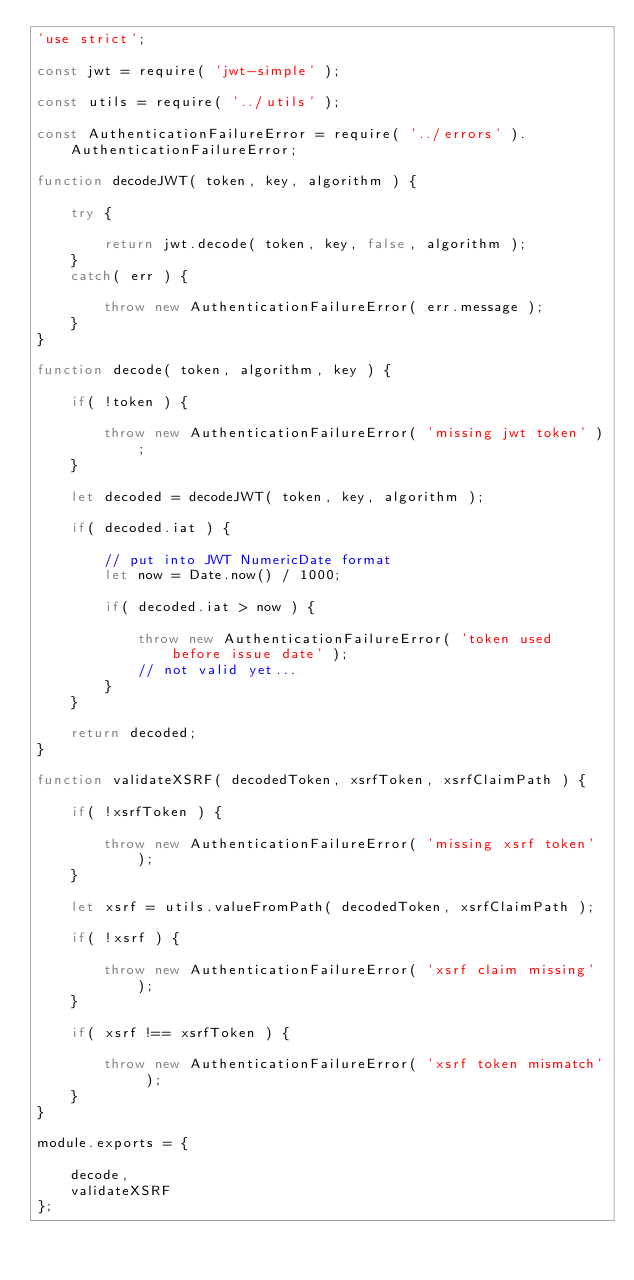<code> <loc_0><loc_0><loc_500><loc_500><_JavaScript_>'use strict';

const jwt = require( 'jwt-simple' );

const utils = require( '../utils' );

const AuthenticationFailureError = require( '../errors' ).AuthenticationFailureError;

function decodeJWT( token, key, algorithm ) {

    try {

        return jwt.decode( token, key, false, algorithm );
    }
    catch( err ) {

        throw new AuthenticationFailureError( err.message );
    }
}

function decode( token, algorithm, key ) {

    if( !token ) {

        throw new AuthenticationFailureError( 'missing jwt token' );
    }

    let decoded = decodeJWT( token, key, algorithm );

    if( decoded.iat ) {

        // put into JWT NumericDate format
        let now = Date.now() / 1000;

        if( decoded.iat > now ) {

            throw new AuthenticationFailureError( 'token used before issue date' );
            // not valid yet...
        }
    }

    return decoded;
}

function validateXSRF( decodedToken, xsrfToken, xsrfClaimPath ) {

    if( !xsrfToken ) {

        throw new AuthenticationFailureError( 'missing xsrf token' );
    }

    let xsrf = utils.valueFromPath( decodedToken, xsrfClaimPath );

    if( !xsrf ) {

        throw new AuthenticationFailureError( 'xsrf claim missing' );
    }

    if( xsrf !== xsrfToken ) {

        throw new AuthenticationFailureError( 'xsrf token mismatch' );
    }
}

module.exports = {

    decode,
    validateXSRF
};
</code> 